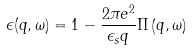Convert formula to latex. <formula><loc_0><loc_0><loc_500><loc_500>\epsilon ( q , \omega ) = 1 - \frac { 2 \pi e ^ { 2 } } { \epsilon _ { s } q } \Pi \left ( q , \omega \right ) \</formula> 